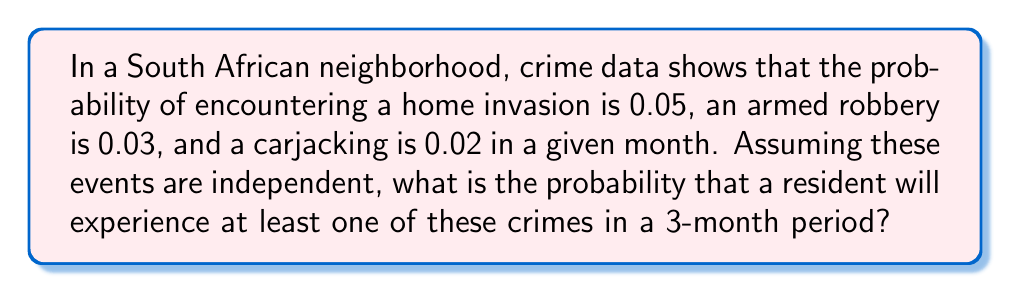Could you help me with this problem? Let's approach this step-by-step:

1) First, let's define our events:
   H: Home invasion
   R: Armed robbery
   C: Carjacking

2) We're given the following probabilities for a single month:
   P(H) = 0.05
   P(R) = 0.03
   P(C) = 0.02

3) To find the probability of at least one of these crimes occurring in 3 months, it's easier to calculate the probability of none of these crimes occurring and then subtract from 1.

4) For a single month, the probability of no crime occurring is:
   P(no crime) = (1 - P(H)) * (1 - P(R)) * (1 - P(C))
                = (1 - 0.05) * (1 - 0.03) * (1 - 0.02)
                = 0.95 * 0.97 * 0.98
                = 0.9033

5) For three months, assuming independence, the probability of no crime occurring is:
   P(no crime in 3 months) = $(0.9033)^3 = 0.7364$

6) Therefore, the probability of at least one crime occurring in 3 months is:
   P(at least one crime in 3 months) = 1 - P(no crime in 3 months)
                                      = $1 - 0.7364 = 0.2636$
Answer: 0.2636 